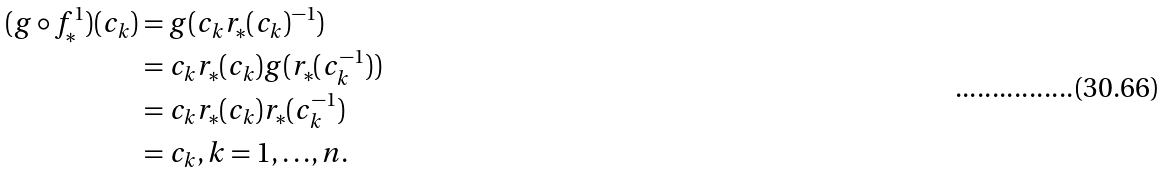Convert formula to latex. <formula><loc_0><loc_0><loc_500><loc_500>( g \circ { f ^ { 1 } _ { * } } ) ( c _ { k } ) & = g ( c _ { k } r _ { * } ( c _ { k } ) ^ { - 1 } ) \\ & = c _ { k } r _ { * } ( c _ { k } ) g ( r _ { * } ( c _ { k } ^ { - 1 } ) ) \\ & = c _ { k } r _ { * } ( c _ { k } ) r _ { * } ( c _ { k } ^ { - 1 } ) \\ & = c _ { k } , k = 1 , { \dots } , n .</formula> 